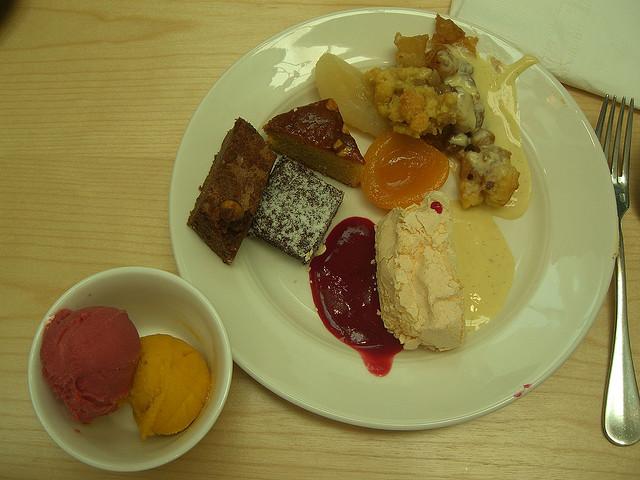How many tools are in this picture?
Give a very brief answer. 1. What fruit is shown?
Keep it brief. Peach. What color is the raspberries?
Quick response, please. Red. What is in the bowl?
Answer briefly. Ice cream. Is there bacon on the plate?
Quick response, please. No. What is sitting on the plate next to the bowl?
Answer briefly. Dessert. Are there any vegetables on the plate?
Write a very short answer. No. Are there green beans on the table?
Answer briefly. No. Would the food in the bowl burn your mouth when eaten as served?
Concise answer only. No. What kind of food is shown?
Answer briefly. Desserts. 